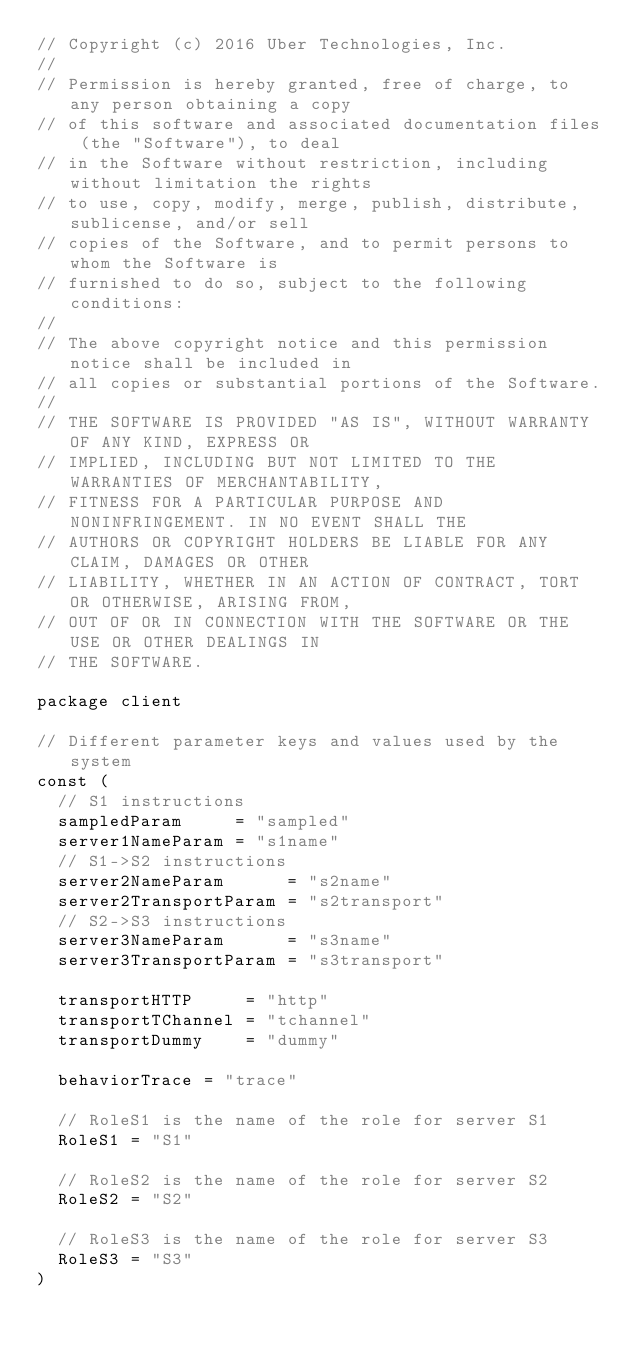<code> <loc_0><loc_0><loc_500><loc_500><_Go_>// Copyright (c) 2016 Uber Technologies, Inc.
//
// Permission is hereby granted, free of charge, to any person obtaining a copy
// of this software and associated documentation files (the "Software"), to deal
// in the Software without restriction, including without limitation the rights
// to use, copy, modify, merge, publish, distribute, sublicense, and/or sell
// copies of the Software, and to permit persons to whom the Software is
// furnished to do so, subject to the following conditions:
//
// The above copyright notice and this permission notice shall be included in
// all copies or substantial portions of the Software.
//
// THE SOFTWARE IS PROVIDED "AS IS", WITHOUT WARRANTY OF ANY KIND, EXPRESS OR
// IMPLIED, INCLUDING BUT NOT LIMITED TO THE WARRANTIES OF MERCHANTABILITY,
// FITNESS FOR A PARTICULAR PURPOSE AND NONINFRINGEMENT. IN NO EVENT SHALL THE
// AUTHORS OR COPYRIGHT HOLDERS BE LIABLE FOR ANY CLAIM, DAMAGES OR OTHER
// LIABILITY, WHETHER IN AN ACTION OF CONTRACT, TORT OR OTHERWISE, ARISING FROM,
// OUT OF OR IN CONNECTION WITH THE SOFTWARE OR THE USE OR OTHER DEALINGS IN
// THE SOFTWARE.

package client

// Different parameter keys and values used by the system
const (
	// S1 instructions
	sampledParam     = "sampled"
	server1NameParam = "s1name"
	// S1->S2 instructions
	server2NameParam      = "s2name"
	server2TransportParam = "s2transport"
	// S2->S3 instructions
	server3NameParam      = "s3name"
	server3TransportParam = "s3transport"

	transportHTTP     = "http"
	transportTChannel = "tchannel"
	transportDummy    = "dummy"

	behaviorTrace = "trace"

	// RoleS1 is the name of the role for server S1
	RoleS1 = "S1"

	// RoleS2 is the name of the role for server S2
	RoleS2 = "S2"

	// RoleS3 is the name of the role for server S3
	RoleS3 = "S3"
)
</code> 